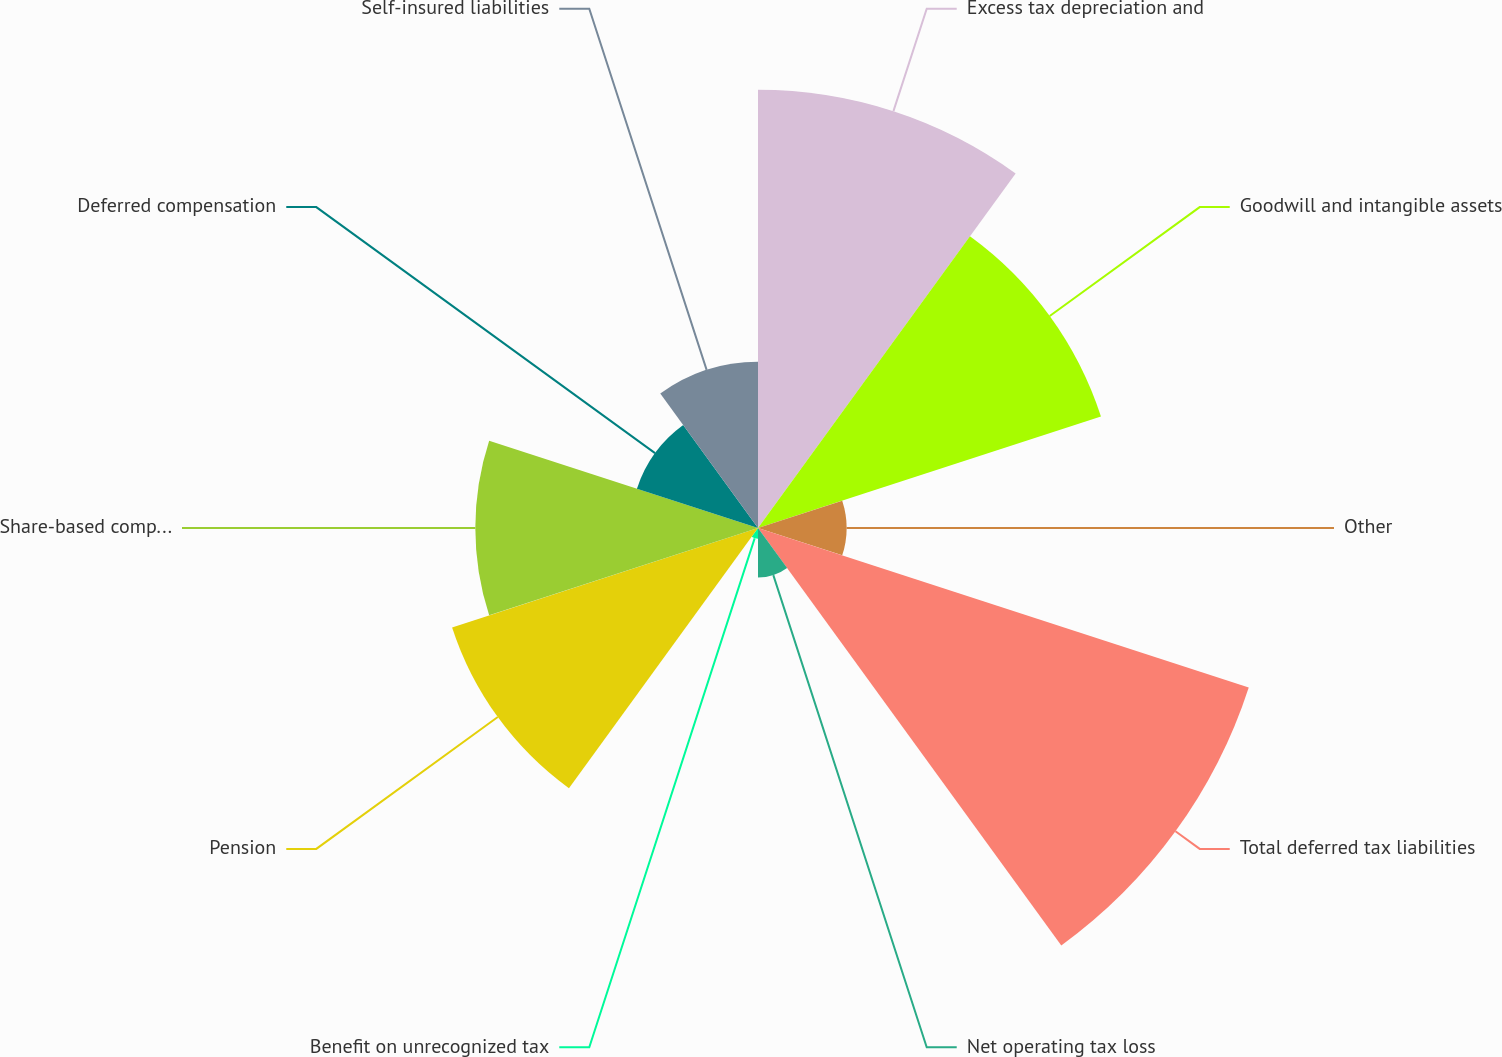Convert chart. <chart><loc_0><loc_0><loc_500><loc_500><pie_chart><fcel>Excess tax depreciation and<fcel>Goodwill and intangible assets<fcel>Other<fcel>Total deferred tax liabilities<fcel>Net operating tax loss<fcel>Benefit on unrecognized tax<fcel>Pension<fcel>Share-based compensation<fcel>Deferred compensation<fcel>Self-insured liabilities<nl><fcel>18.56%<fcel>15.27%<fcel>3.75%<fcel>21.85%<fcel>2.1%<fcel>0.46%<fcel>13.62%<fcel>11.97%<fcel>5.39%<fcel>7.04%<nl></chart> 